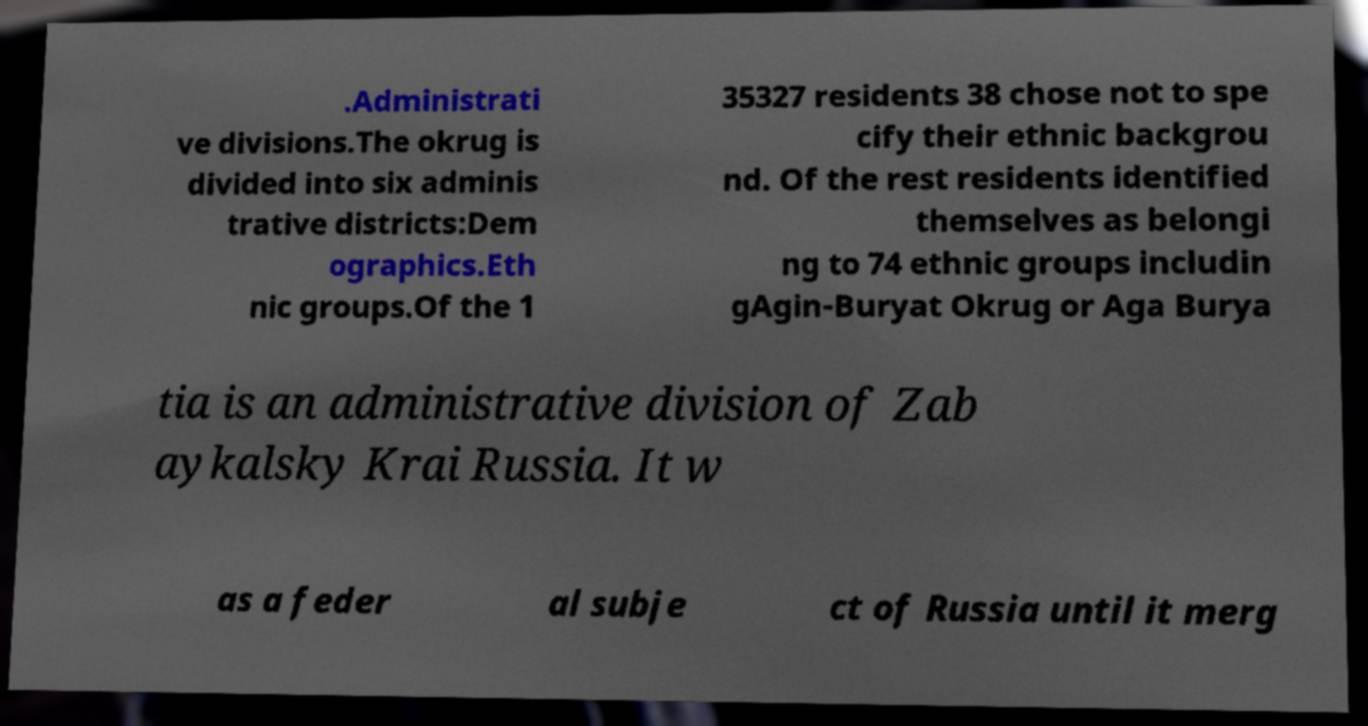There's text embedded in this image that I need extracted. Can you transcribe it verbatim? .Administrati ve divisions.The okrug is divided into six adminis trative districts:Dem ographics.Eth nic groups.Of the 1 35327 residents 38 chose not to spe cify their ethnic backgrou nd. Of the rest residents identified themselves as belongi ng to 74 ethnic groups includin gAgin-Buryat Okrug or Aga Burya tia is an administrative division of Zab aykalsky Krai Russia. It w as a feder al subje ct of Russia until it merg 